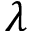<formula> <loc_0><loc_0><loc_500><loc_500>\lambda</formula> 